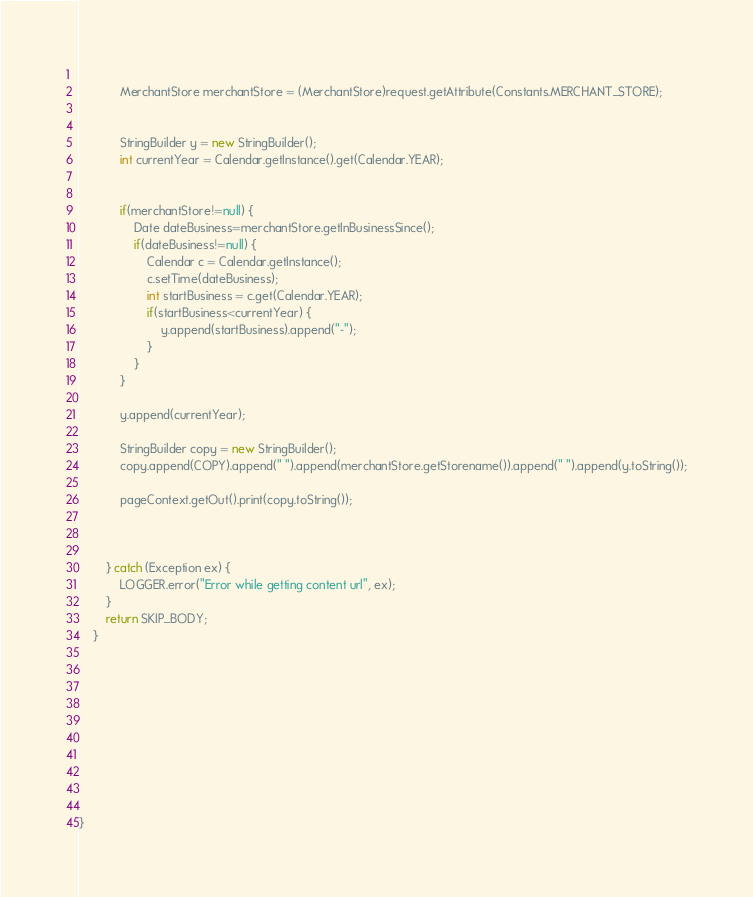<code> <loc_0><loc_0><loc_500><loc_500><_Java_>			
			MerchantStore merchantStore = (MerchantStore)request.getAttribute(Constants.MERCHANT_STORE);

			
			StringBuilder y = new StringBuilder();
			int currentYear = Calendar.getInstance().get(Calendar.YEAR);


			if(merchantStore!=null) {
				Date dateBusiness=merchantStore.getInBusinessSince();
				if(dateBusiness!=null) {
					Calendar c = Calendar.getInstance();
					c.setTime(dateBusiness);
					int startBusiness = c.get(Calendar.YEAR);
					if(startBusiness<currentYear) {
						y.append(startBusiness).append("-");
					}
				}
			}

			y.append(currentYear);
			
			StringBuilder copy = new StringBuilder();
			copy.append(COPY).append(" ").append(merchantStore.getStorename()).append(" ").append(y.toString());

			pageContext.getOut().print(copy.toString());


			
		} catch (Exception ex) {
			LOGGER.error("Error while getting content url", ex);
		}
		return SKIP_BODY;
	}








	

}
</code> 